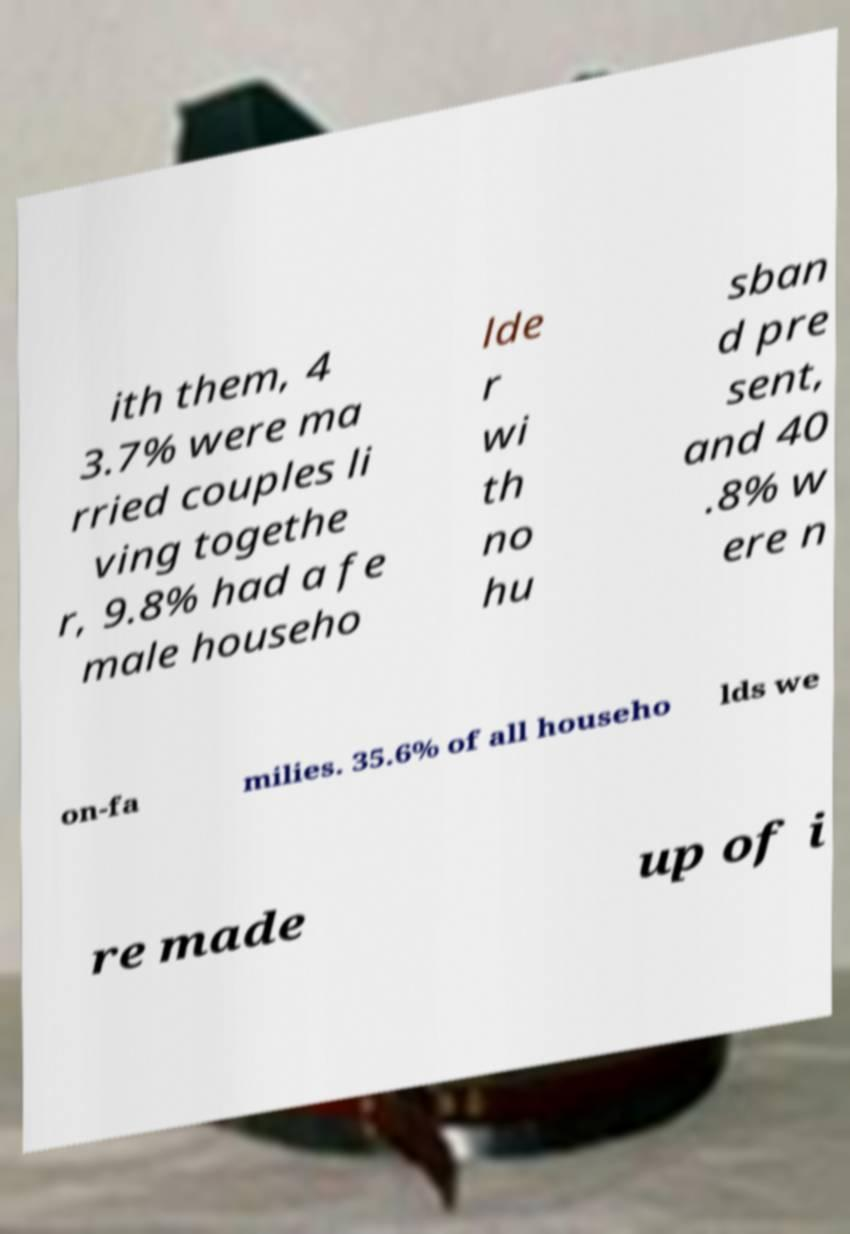There's text embedded in this image that I need extracted. Can you transcribe it verbatim? ith them, 4 3.7% were ma rried couples li ving togethe r, 9.8% had a fe male househo lde r wi th no hu sban d pre sent, and 40 .8% w ere n on-fa milies. 35.6% of all househo lds we re made up of i 